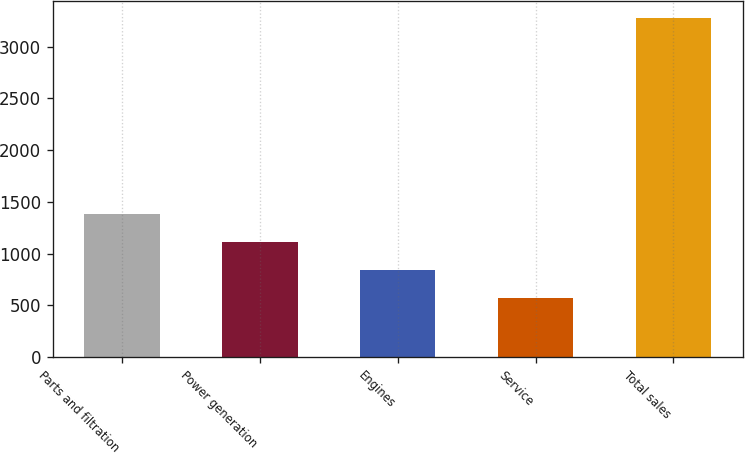Convert chart to OTSL. <chart><loc_0><loc_0><loc_500><loc_500><bar_chart><fcel>Parts and filtration<fcel>Power generation<fcel>Engines<fcel>Service<fcel>Total sales<nl><fcel>1382.1<fcel>1111.4<fcel>840.7<fcel>570<fcel>3277<nl></chart> 